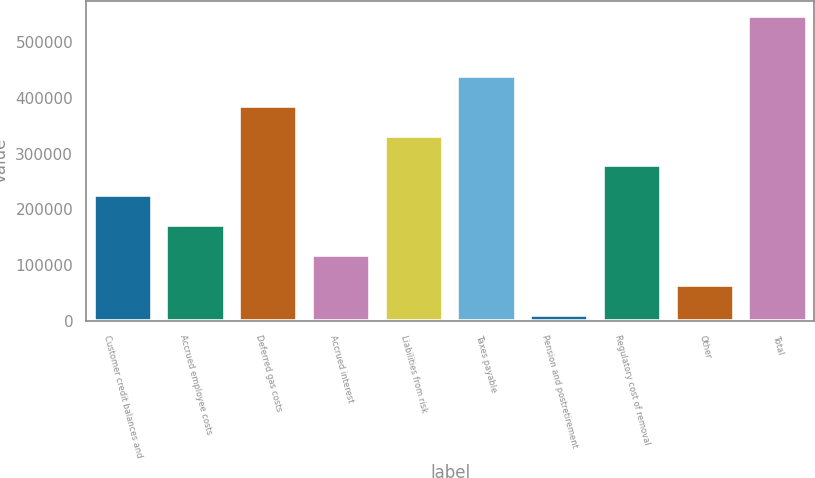Convert chart to OTSL. <chart><loc_0><loc_0><loc_500><loc_500><bar_chart><fcel>Customer credit balances and<fcel>Accrued employee costs<fcel>Deferred gas costs<fcel>Accrued interest<fcel>Liabilities from risk<fcel>Taxes payable<fcel>Pension and postretirement<fcel>Regulatory cost of removal<fcel>Other<fcel>Total<nl><fcel>225112<fcel>171453<fcel>386090<fcel>117794<fcel>332431<fcel>439749<fcel>10475<fcel>278772<fcel>64134.3<fcel>547068<nl></chart> 